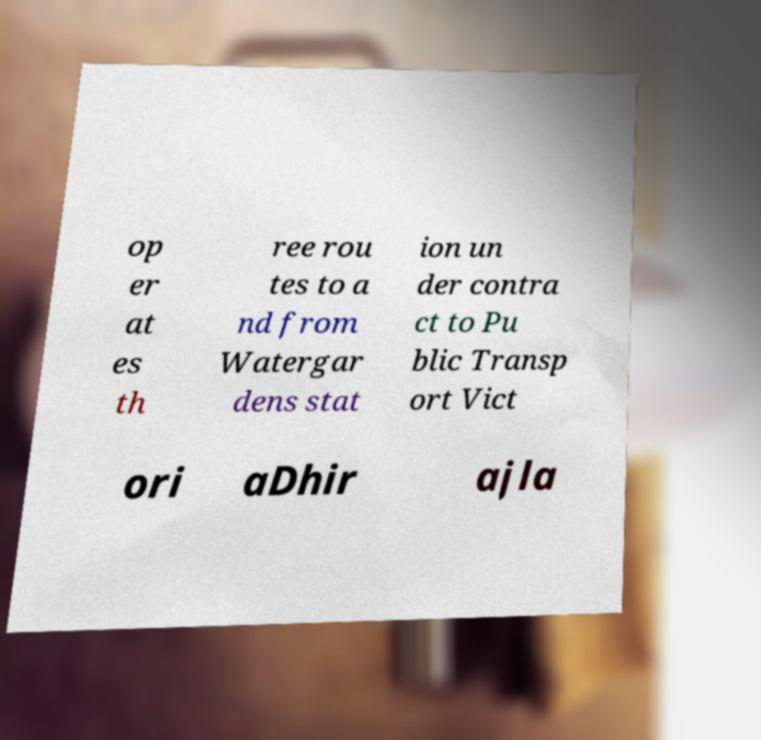For documentation purposes, I need the text within this image transcribed. Could you provide that? op er at es th ree rou tes to a nd from Watergar dens stat ion un der contra ct to Pu blic Transp ort Vict ori aDhir ajla 